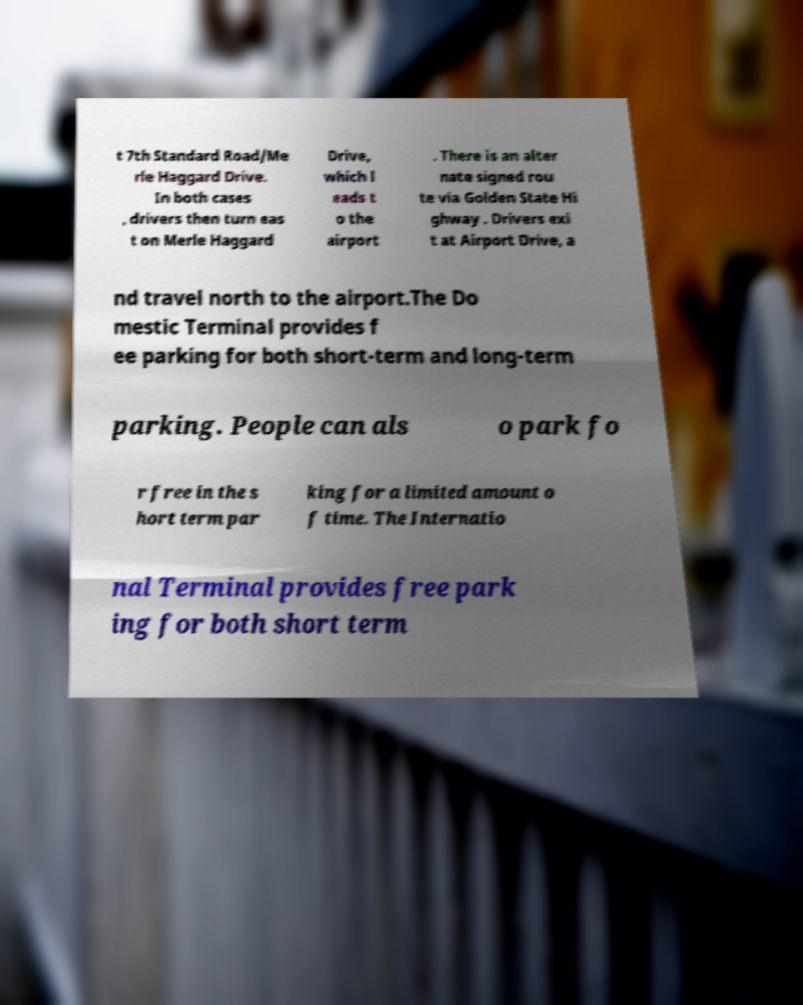Could you extract and type out the text from this image? t 7th Standard Road/Me rle Haggard Drive. In both cases , drivers then turn eas t on Merle Haggard Drive, which l eads t o the airport . There is an alter nate signed rou te via Golden State Hi ghway . Drivers exi t at Airport Drive, a nd travel north to the airport.The Do mestic Terminal provides f ee parking for both short-term and long-term parking. People can als o park fo r free in the s hort term par king for a limited amount o f time. The Internatio nal Terminal provides free park ing for both short term 